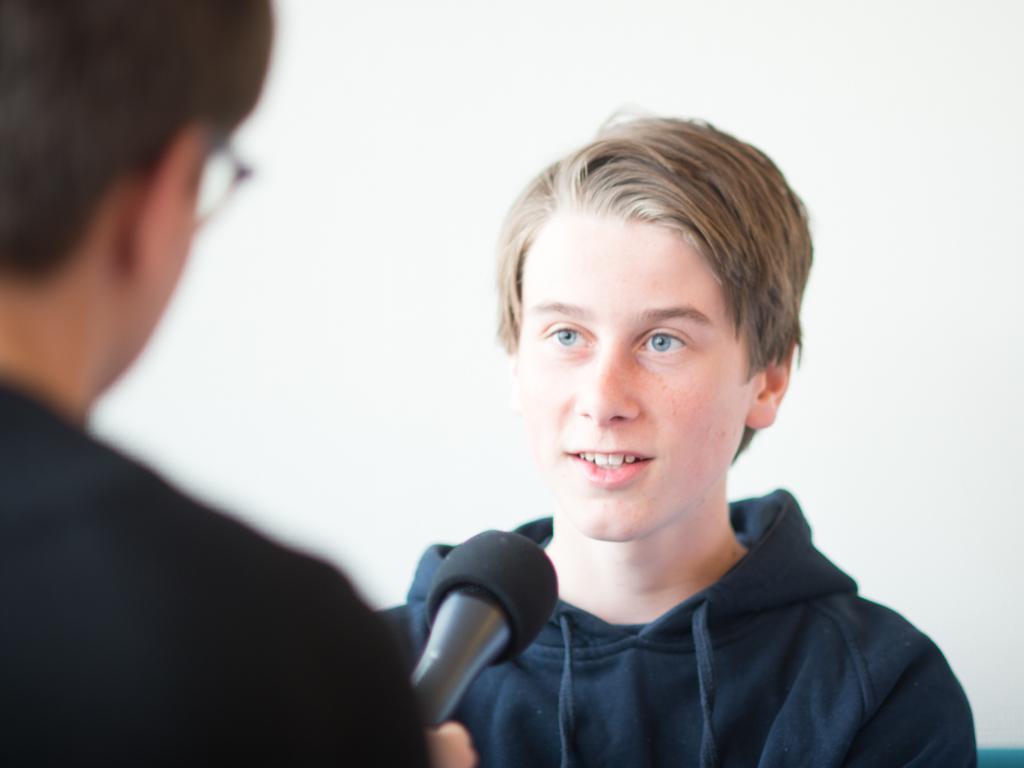Can you describe this image briefly? In this image there are two persons at the middle of the image there is a person wearing sweater holding a microphone. 